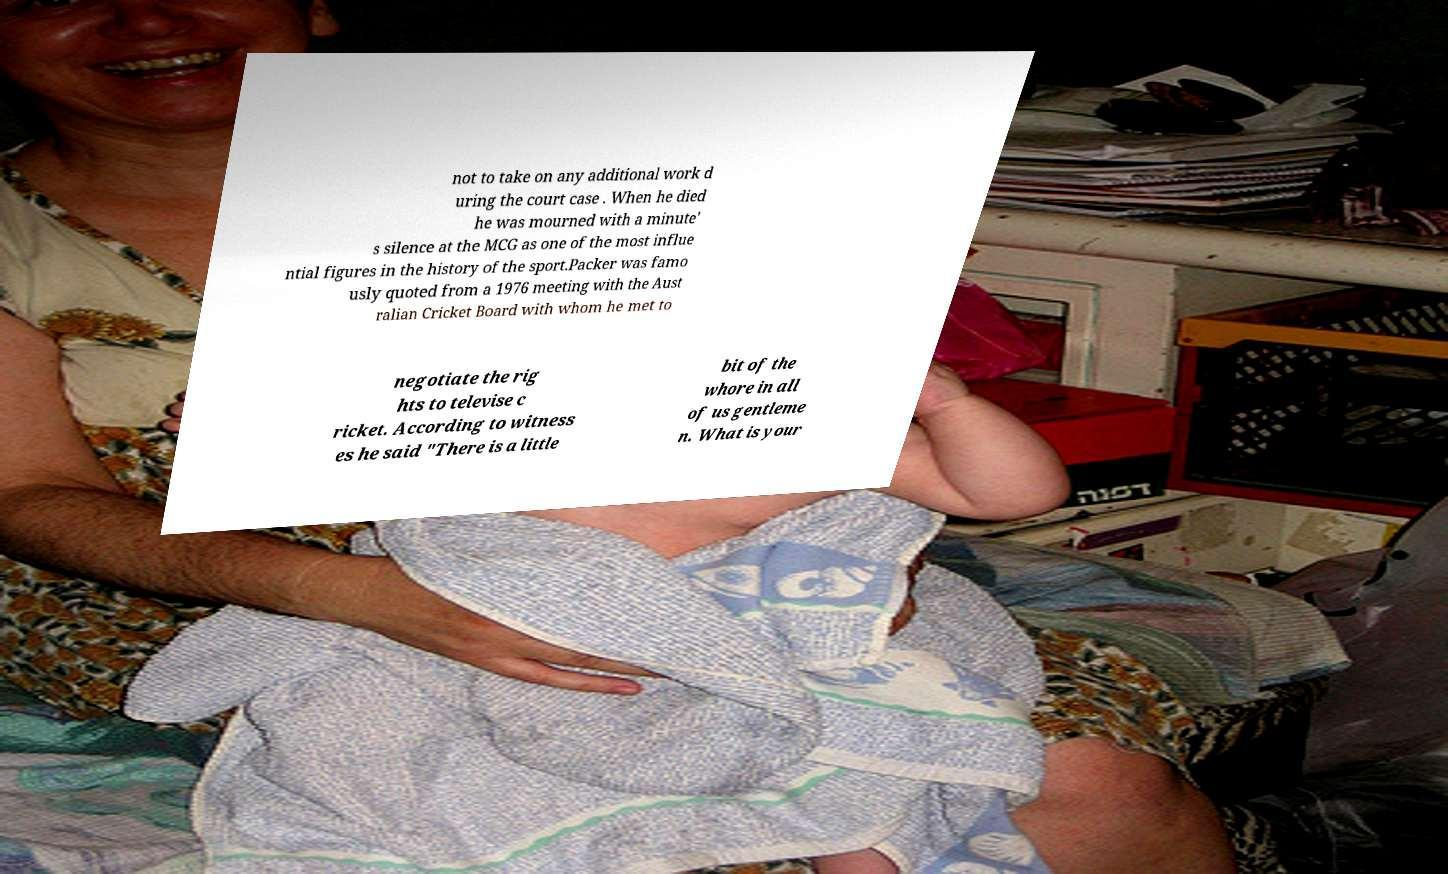There's text embedded in this image that I need extracted. Can you transcribe it verbatim? not to take on any additional work d uring the court case . When he died he was mourned with a minute' s silence at the MCG as one of the most influe ntial figures in the history of the sport.Packer was famo usly quoted from a 1976 meeting with the Aust ralian Cricket Board with whom he met to negotiate the rig hts to televise c ricket. According to witness es he said "There is a little bit of the whore in all of us gentleme n. What is your 